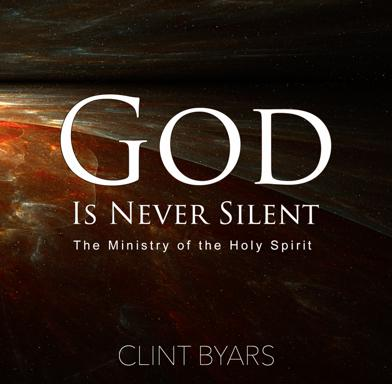Can you discuss the general theme of the book based on its title? Based on its title, 'God Is Never Silent: The Ministry of the Holy Spirit,' the book discusses how God consistently communicates with believers through the Holy Spirit, emphasizing that divine silence is not a lack of presence but a form of spiritual communication. The title implies a deep exploration of the ways the Holy Spirit interacts with and influences the lives of the faithful, providing them not only with guidance and wisdom but also with the reassurance that God is perpetually active and attentive. 